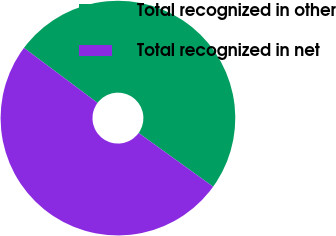<chart> <loc_0><loc_0><loc_500><loc_500><pie_chart><fcel>Total recognized in other<fcel>Total recognized in net<nl><fcel>49.72%<fcel>50.28%<nl></chart> 